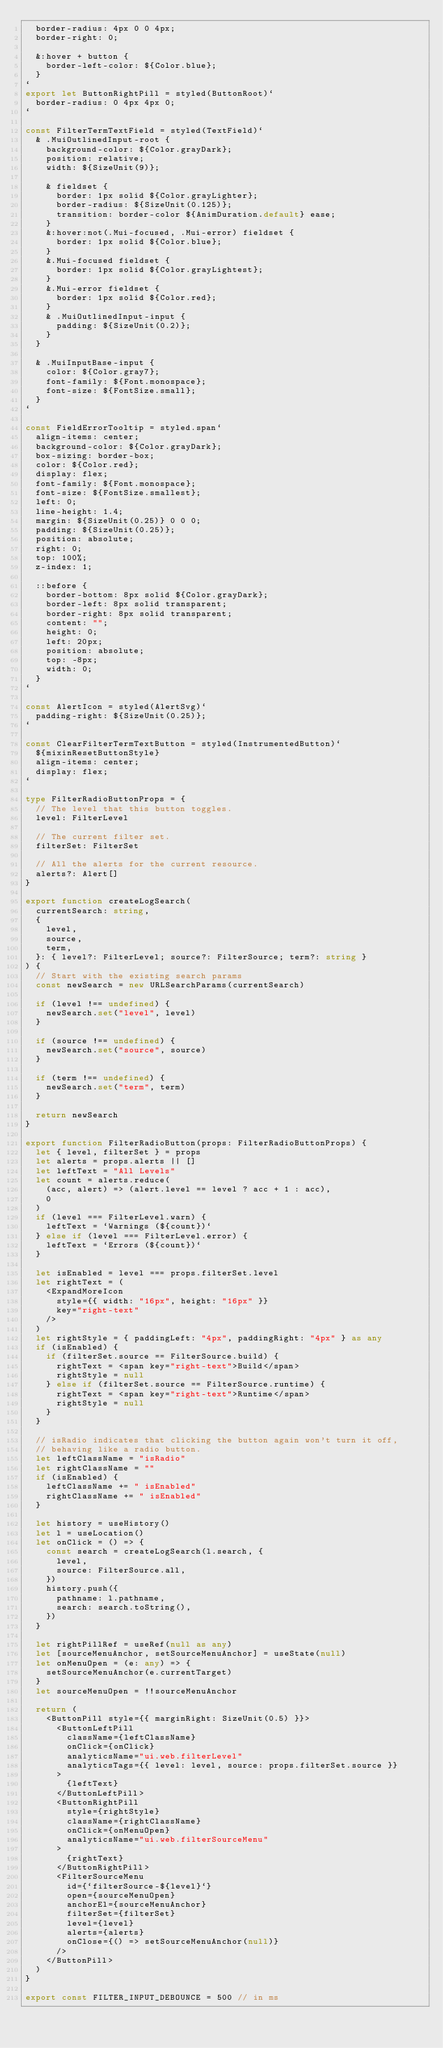Convert code to text. <code><loc_0><loc_0><loc_500><loc_500><_TypeScript_>  border-radius: 4px 0 0 4px;
  border-right: 0;

  &:hover + button {
    border-left-color: ${Color.blue};
  }
`
export let ButtonRightPill = styled(ButtonRoot)`
  border-radius: 0 4px 4px 0;
`

const FilterTermTextField = styled(TextField)`
  & .MuiOutlinedInput-root {
    background-color: ${Color.grayDark};
    position: relative;
    width: ${SizeUnit(9)};

    & fieldset {
      border: 1px solid ${Color.grayLighter};
      border-radius: ${SizeUnit(0.125)};
      transition: border-color ${AnimDuration.default} ease;
    }
    &:hover:not(.Mui-focused, .Mui-error) fieldset {
      border: 1px solid ${Color.blue};
    }
    &.Mui-focused fieldset {
      border: 1px solid ${Color.grayLightest};
    }
    &.Mui-error fieldset {
      border: 1px solid ${Color.red};
    }
    & .MuiOutlinedInput-input {
      padding: ${SizeUnit(0.2)};
    }
  }

  & .MuiInputBase-input {
    color: ${Color.gray7};
    font-family: ${Font.monospace};
    font-size: ${FontSize.small};
  }
`

const FieldErrorTooltip = styled.span`
  align-items: center;
  background-color: ${Color.grayDark};
  box-sizing: border-box;
  color: ${Color.red};
  display: flex;
  font-family: ${Font.monospace};
  font-size: ${FontSize.smallest};
  left: 0;
  line-height: 1.4;
  margin: ${SizeUnit(0.25)} 0 0 0;
  padding: ${SizeUnit(0.25)};
  position: absolute;
  right: 0;
  top: 100%;
  z-index: 1;

  ::before {
    border-bottom: 8px solid ${Color.grayDark};
    border-left: 8px solid transparent;
    border-right: 8px solid transparent;
    content: "";
    height: 0;
    left: 20px;
    position: absolute;
    top: -8px;
    width: 0;
  }
`

const AlertIcon = styled(AlertSvg)`
  padding-right: ${SizeUnit(0.25)};
`

const ClearFilterTermTextButton = styled(InstrumentedButton)`
  ${mixinResetButtonStyle}
  align-items: center;
  display: flex;
`

type FilterRadioButtonProps = {
  // The level that this button toggles.
  level: FilterLevel

  // The current filter set.
  filterSet: FilterSet

  // All the alerts for the current resource.
  alerts?: Alert[]
}

export function createLogSearch(
  currentSearch: string,
  {
    level,
    source,
    term,
  }: { level?: FilterLevel; source?: FilterSource; term?: string }
) {
  // Start with the existing search params
  const newSearch = new URLSearchParams(currentSearch)

  if (level !== undefined) {
    newSearch.set("level", level)
  }

  if (source !== undefined) {
    newSearch.set("source", source)
  }

  if (term !== undefined) {
    newSearch.set("term", term)
  }

  return newSearch
}

export function FilterRadioButton(props: FilterRadioButtonProps) {
  let { level, filterSet } = props
  let alerts = props.alerts || []
  let leftText = "All Levels"
  let count = alerts.reduce(
    (acc, alert) => (alert.level == level ? acc + 1 : acc),
    0
  )
  if (level === FilterLevel.warn) {
    leftText = `Warnings (${count})`
  } else if (level === FilterLevel.error) {
    leftText = `Errors (${count})`
  }

  let isEnabled = level === props.filterSet.level
  let rightText = (
    <ExpandMoreIcon
      style={{ width: "16px", height: "16px" }}
      key="right-text"
    />
  )
  let rightStyle = { paddingLeft: "4px", paddingRight: "4px" } as any
  if (isEnabled) {
    if (filterSet.source == FilterSource.build) {
      rightText = <span key="right-text">Build</span>
      rightStyle = null
    } else if (filterSet.source == FilterSource.runtime) {
      rightText = <span key="right-text">Runtime</span>
      rightStyle = null
    }
  }

  // isRadio indicates that clicking the button again won't turn it off,
  // behaving like a radio button.
  let leftClassName = "isRadio"
  let rightClassName = ""
  if (isEnabled) {
    leftClassName += " isEnabled"
    rightClassName += " isEnabled"
  }

  let history = useHistory()
  let l = useLocation()
  let onClick = () => {
    const search = createLogSearch(l.search, {
      level,
      source: FilterSource.all,
    })
    history.push({
      pathname: l.pathname,
      search: search.toString(),
    })
  }

  let rightPillRef = useRef(null as any)
  let [sourceMenuAnchor, setSourceMenuAnchor] = useState(null)
  let onMenuOpen = (e: any) => {
    setSourceMenuAnchor(e.currentTarget)
  }
  let sourceMenuOpen = !!sourceMenuAnchor

  return (
    <ButtonPill style={{ marginRight: SizeUnit(0.5) }}>
      <ButtonLeftPill
        className={leftClassName}
        onClick={onClick}
        analyticsName="ui.web.filterLevel"
        analyticsTags={{ level: level, source: props.filterSet.source }}
      >
        {leftText}
      </ButtonLeftPill>
      <ButtonRightPill
        style={rightStyle}
        className={rightClassName}
        onClick={onMenuOpen}
        analyticsName="ui.web.filterSourceMenu"
      >
        {rightText}
      </ButtonRightPill>
      <FilterSourceMenu
        id={`filterSource-${level}`}
        open={sourceMenuOpen}
        anchorEl={sourceMenuAnchor}
        filterSet={filterSet}
        level={level}
        alerts={alerts}
        onClose={() => setSourceMenuAnchor(null)}
      />
    </ButtonPill>
  )
}

export const FILTER_INPUT_DEBOUNCE = 500 // in ms</code> 